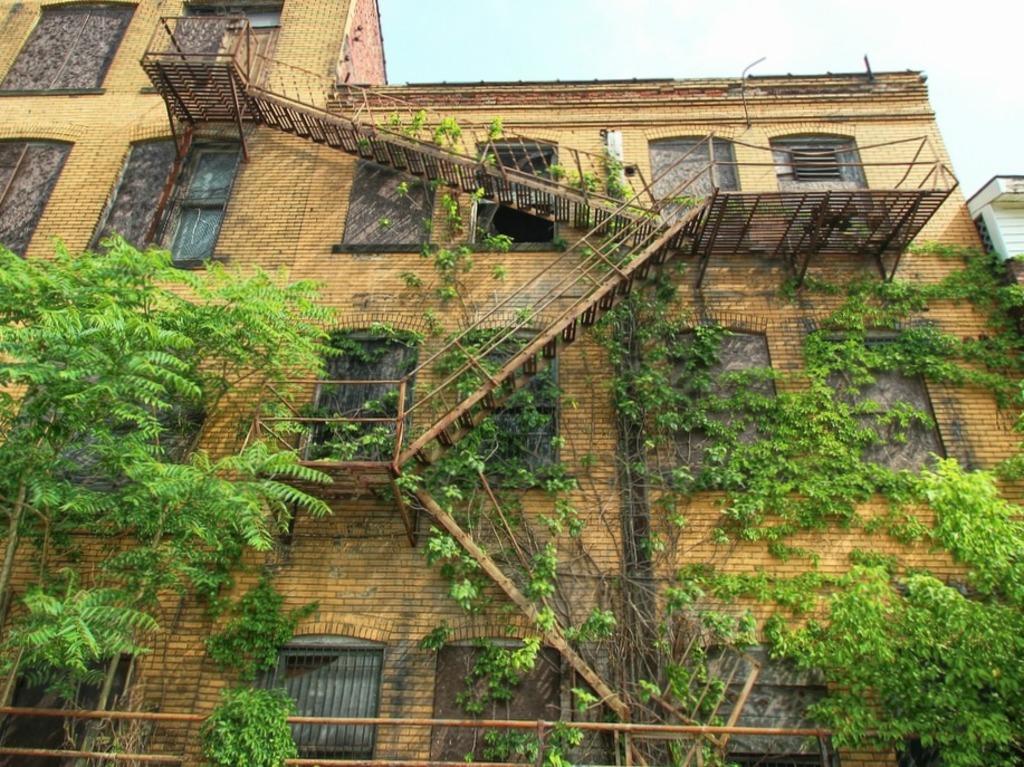Could you give a brief overview of what you see in this image? In this picture we can see a building, few trees, metal rods and steps. 